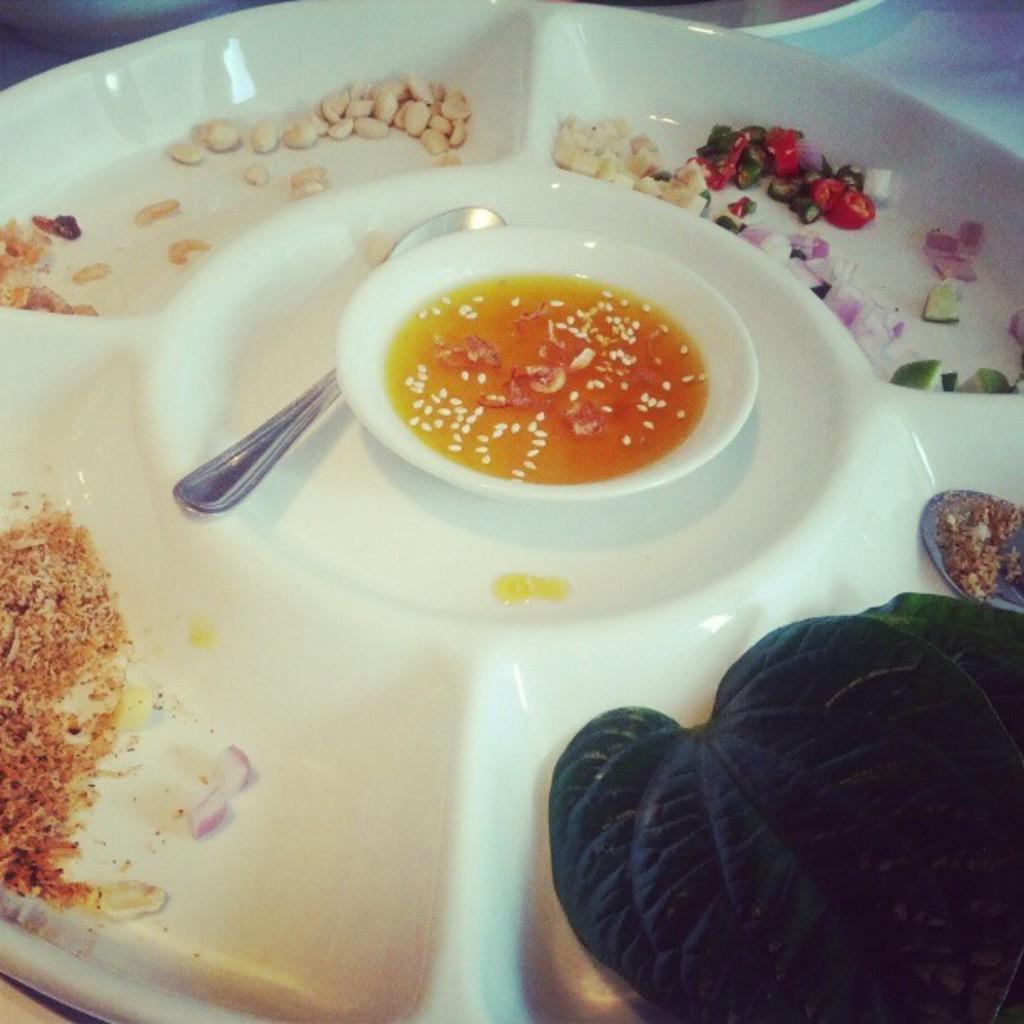Describe this image in one or two sentences. In the picture we can see a plate on it we can see a bowl with a soup and a spoon beside it and we can see some leaves, some powder, some vegetable slices and grains. 